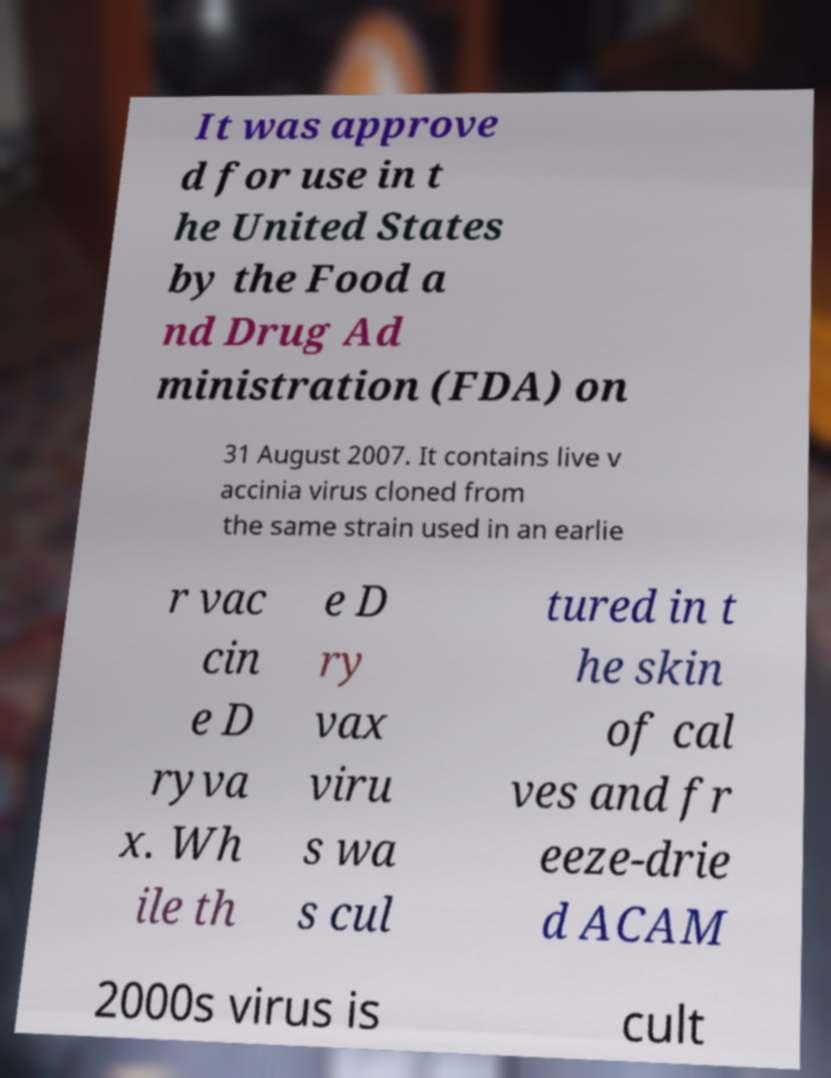What messages or text are displayed in this image? I need them in a readable, typed format. It was approve d for use in t he United States by the Food a nd Drug Ad ministration (FDA) on 31 August 2007. It contains live v accinia virus cloned from the same strain used in an earlie r vac cin e D ryva x. Wh ile th e D ry vax viru s wa s cul tured in t he skin of cal ves and fr eeze-drie d ACAM 2000s virus is cult 